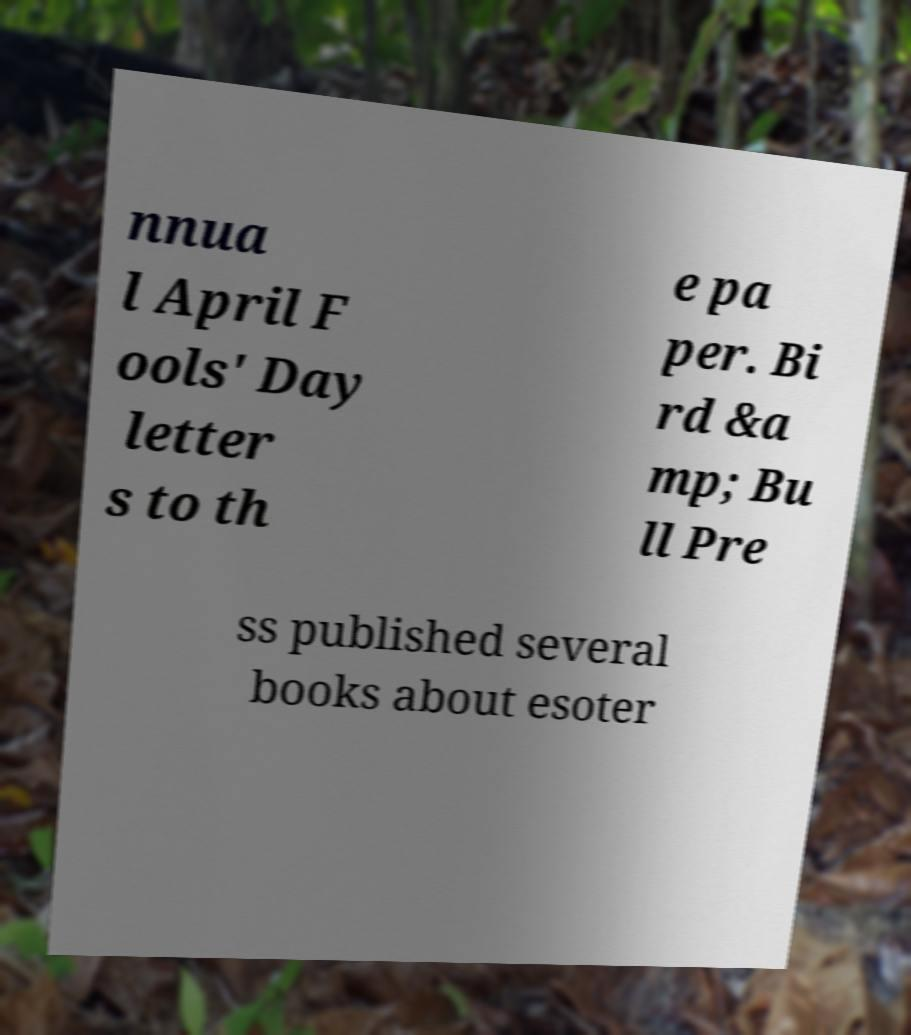Please identify and transcribe the text found in this image. nnua l April F ools' Day letter s to th e pa per. Bi rd &a mp; Bu ll Pre ss published several books about esoter 